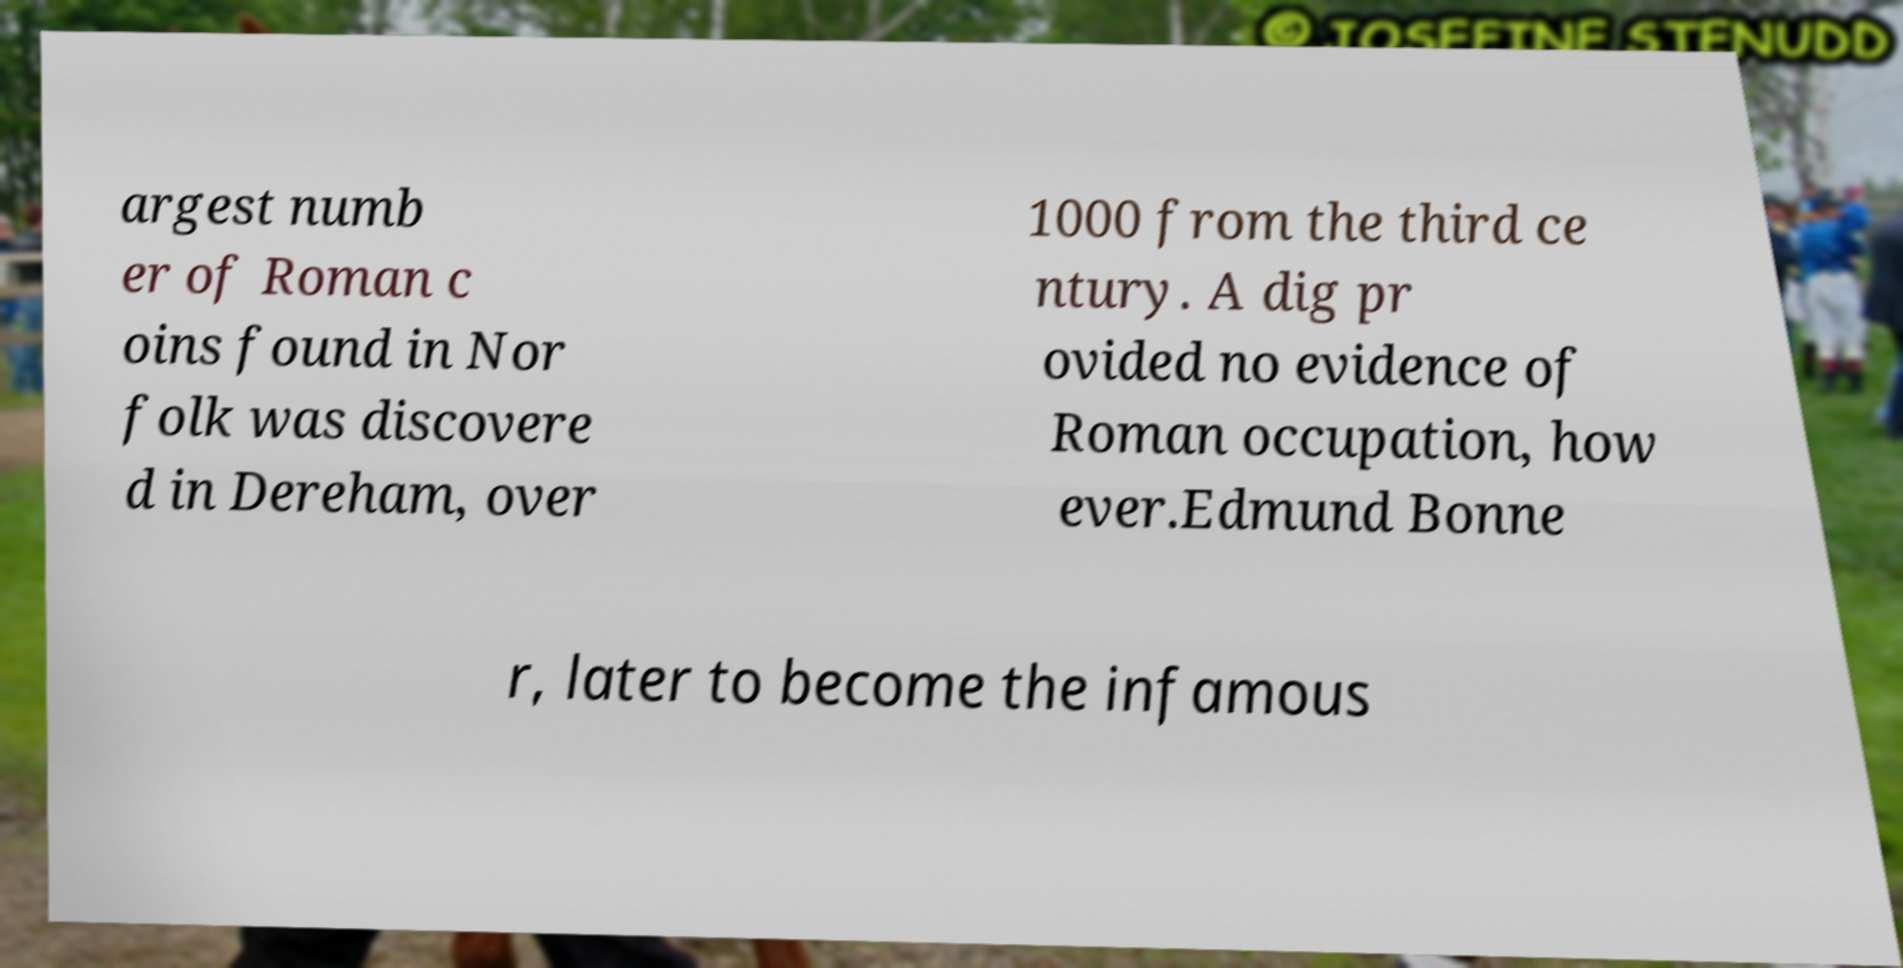There's text embedded in this image that I need extracted. Can you transcribe it verbatim? argest numb er of Roman c oins found in Nor folk was discovere d in Dereham, over 1000 from the third ce ntury. A dig pr ovided no evidence of Roman occupation, how ever.Edmund Bonne r, later to become the infamous 